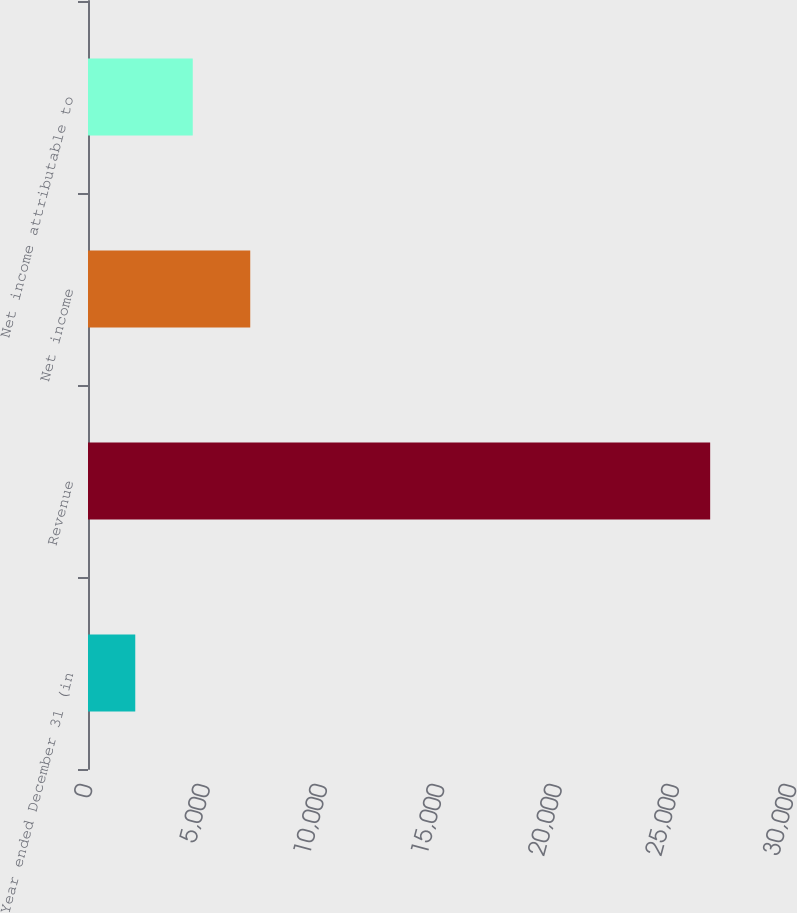Convert chart. <chart><loc_0><loc_0><loc_500><loc_500><bar_chart><fcel>Year ended December 31 (in<fcel>Revenue<fcel>Net income<fcel>Net income attributable to<nl><fcel>2014<fcel>26513<fcel>6913.8<fcel>4463.9<nl></chart> 